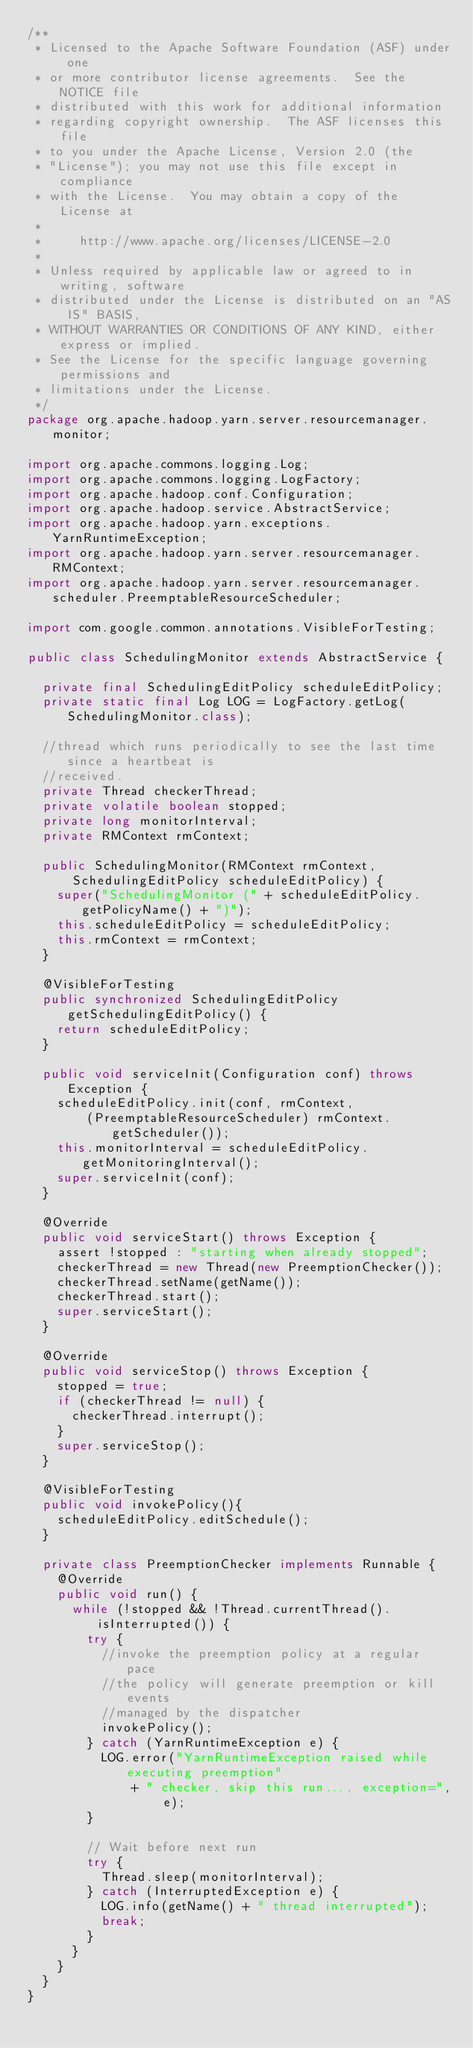<code> <loc_0><loc_0><loc_500><loc_500><_Java_>/**
 * Licensed to the Apache Software Foundation (ASF) under one
 * or more contributor license agreements.  See the NOTICE file
 * distributed with this work for additional information
 * regarding copyright ownership.  The ASF licenses this file
 * to you under the Apache License, Version 2.0 (the
 * "License"); you may not use this file except in compliance
 * with the License.  You may obtain a copy of the License at
 *
 *     http://www.apache.org/licenses/LICENSE-2.0
 *
 * Unless required by applicable law or agreed to in writing, software
 * distributed under the License is distributed on an "AS IS" BASIS,
 * WITHOUT WARRANTIES OR CONDITIONS OF ANY KIND, either express or implied.
 * See the License for the specific language governing permissions and
 * limitations under the License.
 */
package org.apache.hadoop.yarn.server.resourcemanager.monitor;

import org.apache.commons.logging.Log;
import org.apache.commons.logging.LogFactory;
import org.apache.hadoop.conf.Configuration;
import org.apache.hadoop.service.AbstractService;
import org.apache.hadoop.yarn.exceptions.YarnRuntimeException;
import org.apache.hadoop.yarn.server.resourcemanager.RMContext;
import org.apache.hadoop.yarn.server.resourcemanager.scheduler.PreemptableResourceScheduler;

import com.google.common.annotations.VisibleForTesting;

public class SchedulingMonitor extends AbstractService {

  private final SchedulingEditPolicy scheduleEditPolicy;
  private static final Log LOG = LogFactory.getLog(SchedulingMonitor.class);

  //thread which runs periodically to see the last time since a heartbeat is
  //received.
  private Thread checkerThread;
  private volatile boolean stopped;
  private long monitorInterval;
  private RMContext rmContext;

  public SchedulingMonitor(RMContext rmContext,
      SchedulingEditPolicy scheduleEditPolicy) {
    super("SchedulingMonitor (" + scheduleEditPolicy.getPolicyName() + ")");
    this.scheduleEditPolicy = scheduleEditPolicy;
    this.rmContext = rmContext;
  }

  @VisibleForTesting
  public synchronized SchedulingEditPolicy getSchedulingEditPolicy() {
    return scheduleEditPolicy;
  }

  public void serviceInit(Configuration conf) throws Exception {
    scheduleEditPolicy.init(conf, rmContext,
        (PreemptableResourceScheduler) rmContext.getScheduler());
    this.monitorInterval = scheduleEditPolicy.getMonitoringInterval();
    super.serviceInit(conf);
  }

  @Override
  public void serviceStart() throws Exception {
    assert !stopped : "starting when already stopped";
    checkerThread = new Thread(new PreemptionChecker());
    checkerThread.setName(getName());
    checkerThread.start();
    super.serviceStart();
  }

  @Override
  public void serviceStop() throws Exception {
    stopped = true;
    if (checkerThread != null) {
      checkerThread.interrupt();
    }
    super.serviceStop();
  }

  @VisibleForTesting
  public void invokePolicy(){
    scheduleEditPolicy.editSchedule();
  }

  private class PreemptionChecker implements Runnable {
    @Override
    public void run() {
      while (!stopped && !Thread.currentThread().isInterrupted()) {
        try {
          //invoke the preemption policy at a regular pace
          //the policy will generate preemption or kill events
          //managed by the dispatcher
          invokePolicy();
        } catch (YarnRuntimeException e) {
          LOG.error("YarnRuntimeException raised while executing preemption"
              + " checker, skip this run..., exception=", e);
        }

        // Wait before next run
        try {
          Thread.sleep(monitorInterval);
        } catch (InterruptedException e) {
          LOG.info(getName() + " thread interrupted");
          break;
        }
      }
    }
  }
}
</code> 